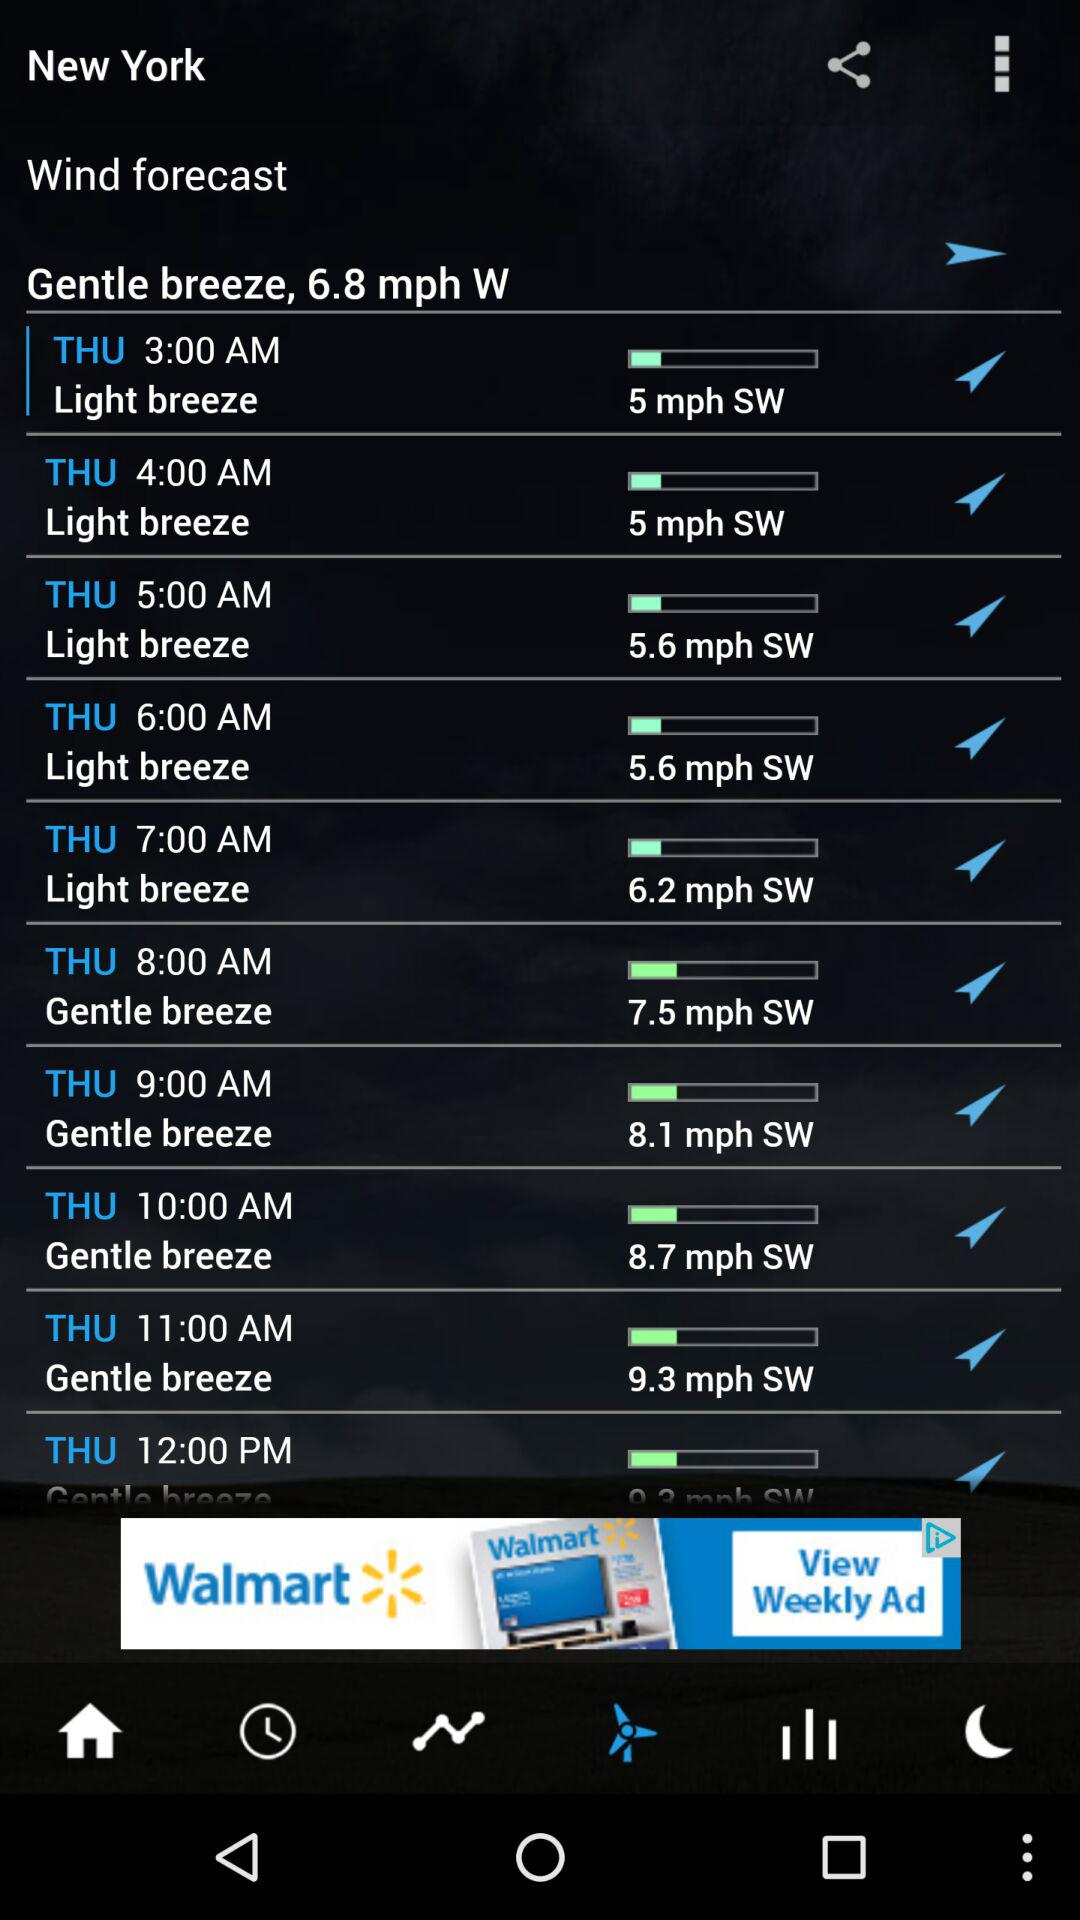What location of the "Wind forecast" is this? The location is New York. 